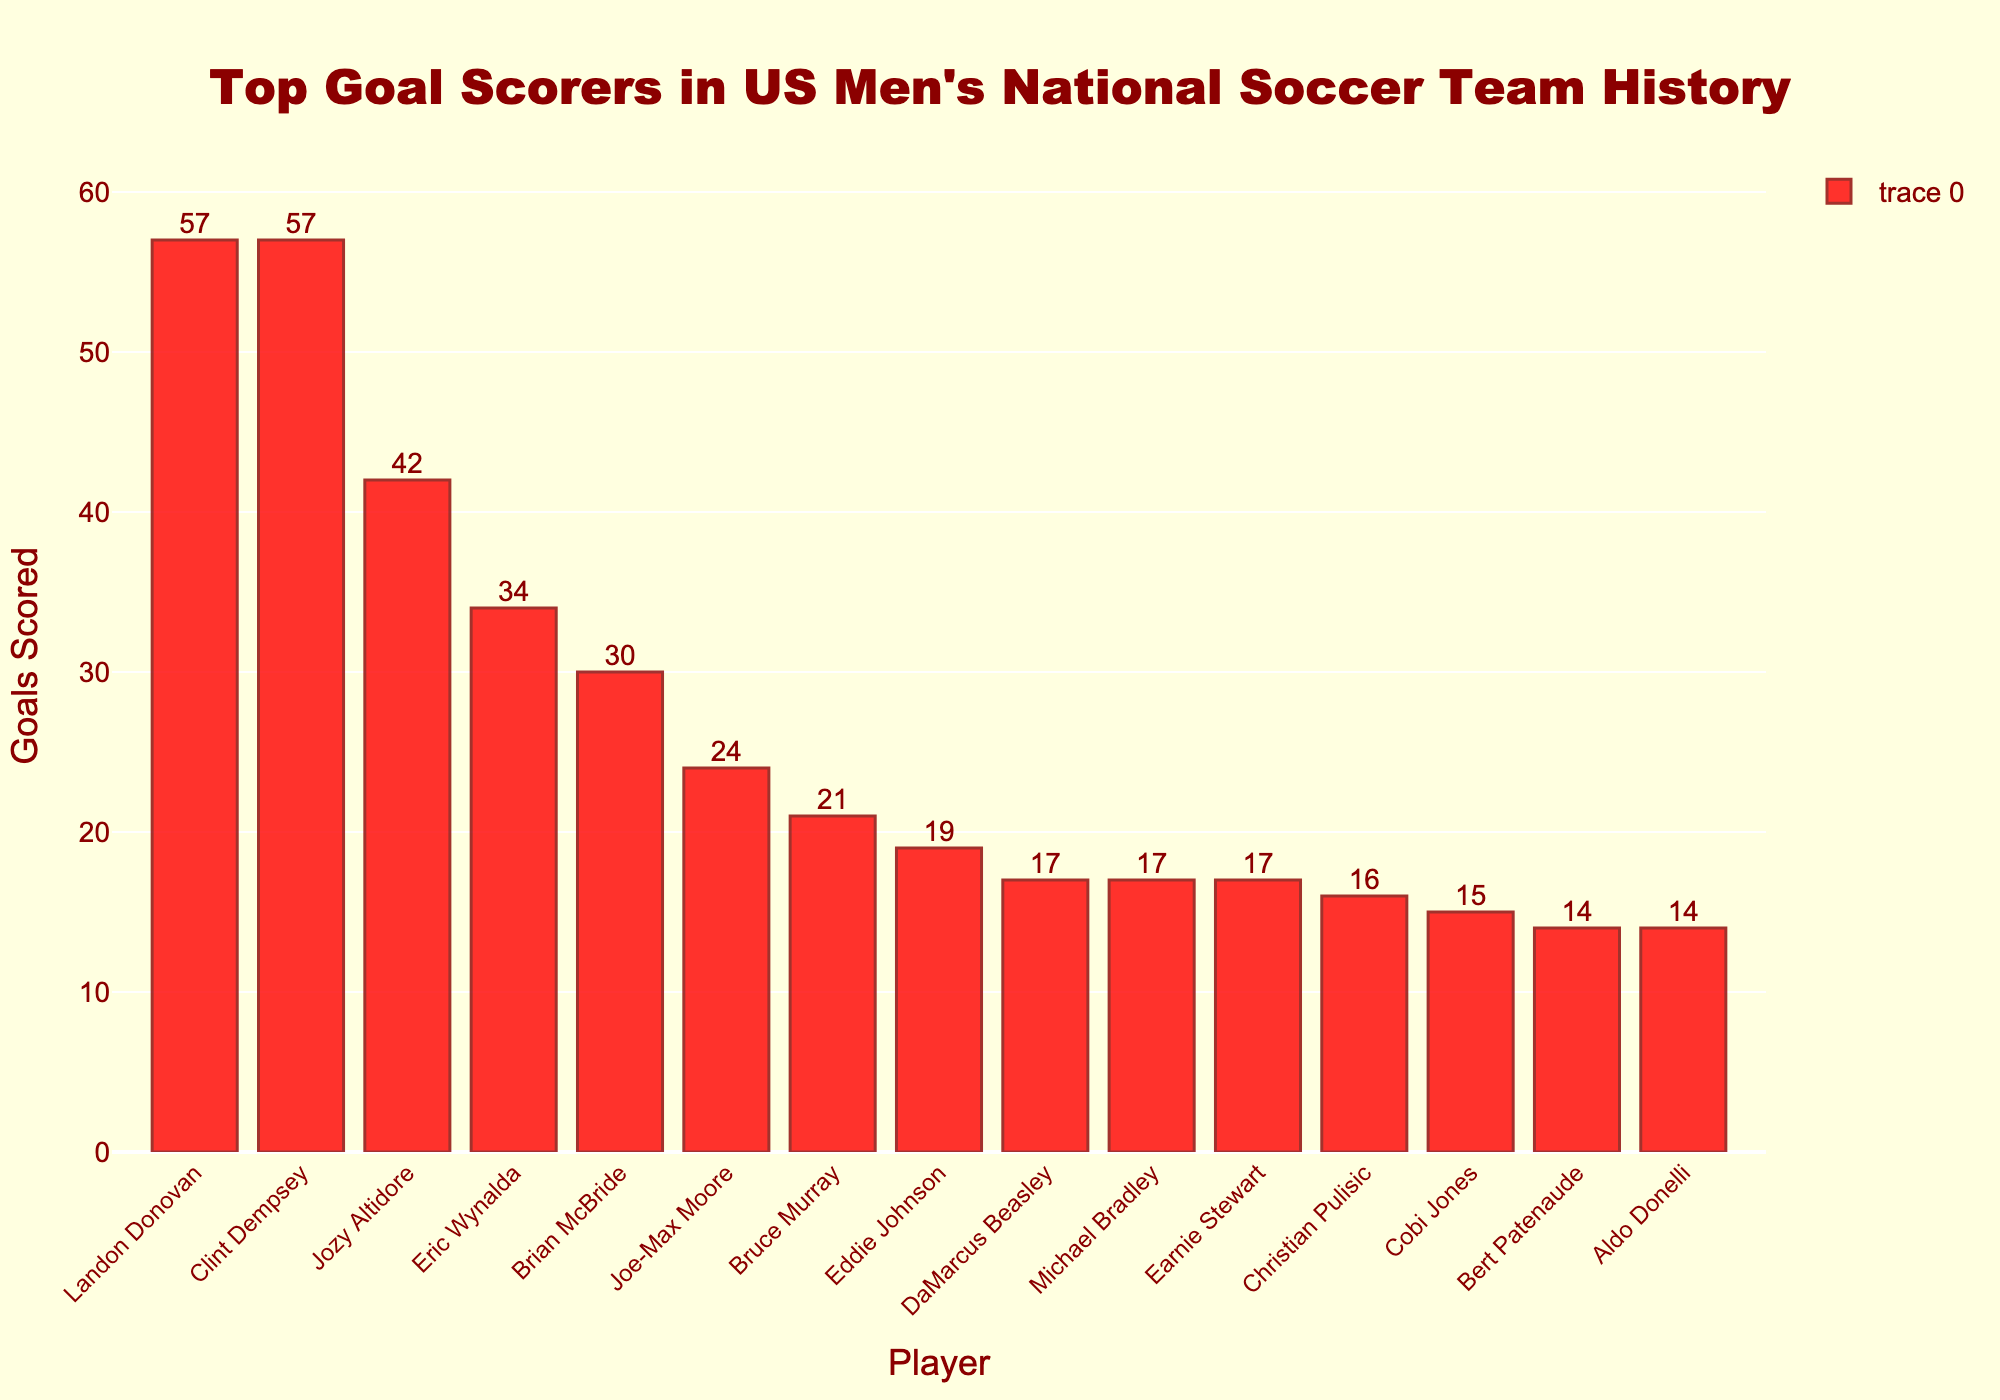Who are the top two all-time leading goal scorers in the US Men's National Soccer Team? The two players at the top of the bar chart have the highest bars and the same number of goals. Their names are Clint Dempsey and Landon Donovan, each having 57 goals.
Answer: Clint Dempsey and Landon Donovan Who has scored 42 goals for the US Men's National Soccer Team? By looking at the bar heights and the numbers on top of each bar, Jozy Altidore is the player with 42 goals.
Answer: Jozy Altidore What's the difference in the number of goals between the player with the 3rd highest and 4th highest goals? The player with the 3rd highest goals is Jozy Altidore with 42 goals, and the player with the 4th highest goals is Eric Wynalda with 34 goals. The difference is 42 - 34.
Answer: 8 How many goals have Joe-Max Moore and Eddie Johnson scored combined? Joe-Max Moore has 24 goals, and Eddie Johnson has 19 goals. Adding these together gives 24 + 19.
Answer: 43 Who scored more goals, Brian McBride or Michael Bradley? Comparing the bars and the numbers on top, Brian McBride has 30 goals while Michael Bradley has 17 goals.
Answer: Brian McBride Which player ranks 10th in terms of goals scored? The 10th bar in the sorted chart represents the player with the 10th highest goals, which is Christian Pulisic with 16 goals.
Answer: Christian Pulisic What is the average number of goals scored by the top 5 goal scorers? The top 5 scorers are Clint Dempsey (57), Landon Donovan (57), Jozy Altidore (42), Eric Wynalda (34), and Brian McBride (30). Adding these gives 57 + 57 + 42 + 34 + 30 = 220. The average is 220 / 5.
Answer: 44 How many players scored 17 goals? By looking at the bars, three players (DaMarcus Beasley, Michael Bradley, and Earnie Stewart) have scores of 17 goals each.
Answer: 3 Which player has the least number of goals among the top 10 list? By identifying the shortest bar in the chart, Bert Patenaude and Aldo Donelli both have the least number of goals, which is 14.
Answer: Bert Patenaude and Aldo Donelli What is the total number of goals scored by the top 3 players? The top 3 players are Clint Dempsey, Landon Donovan, and Jozy Altidore. Their total goals are 57 + 57 + 42.
Answer: 156 